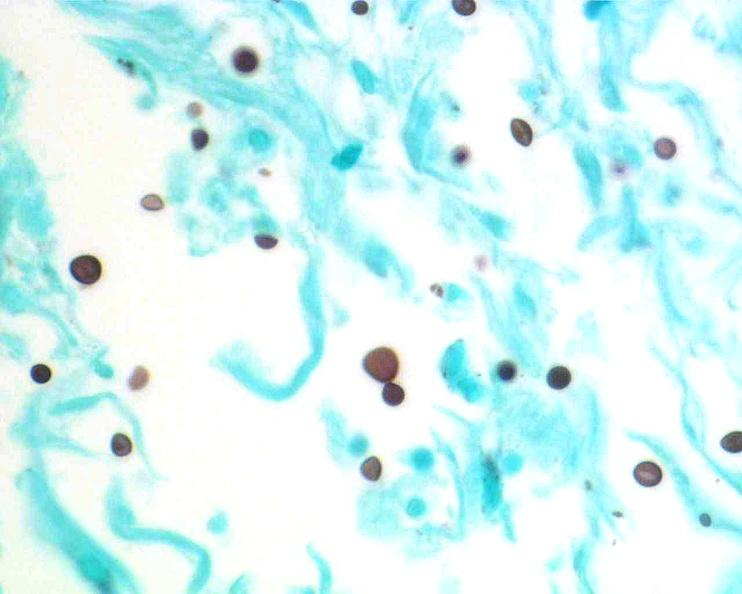do vasculature stain?
Answer the question using a single word or phrase. No 